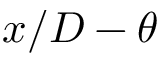<formula> <loc_0><loc_0><loc_500><loc_500>x / D - \theta</formula> 